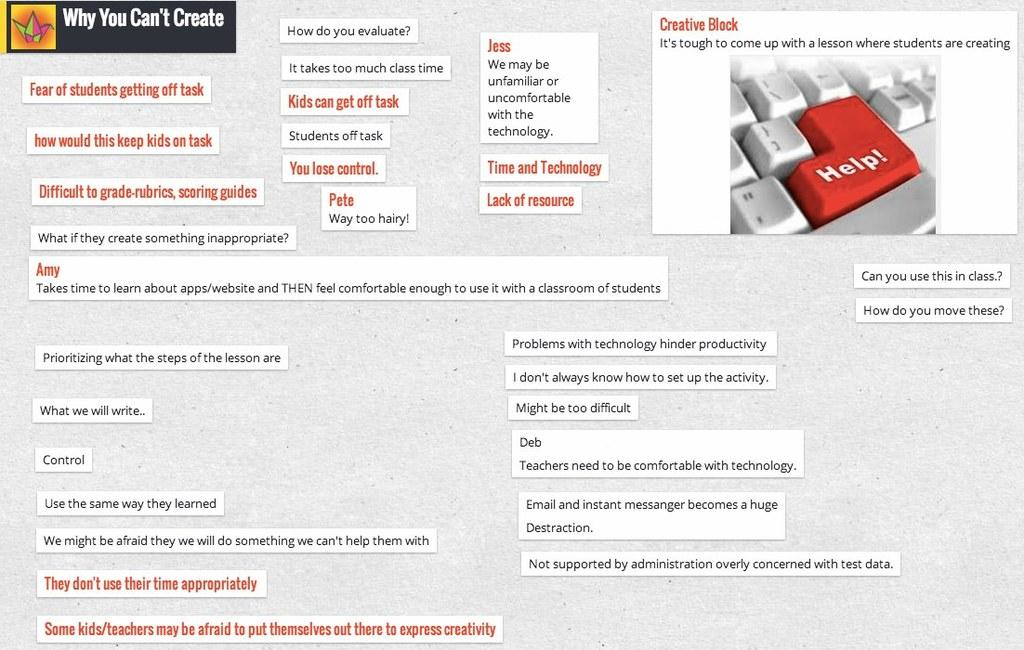What type of content is displayed in the image? The image contains a screenshot of a picture. What else can be seen in the screenshot besides the picture? There is text present in the screenshot. Can you describe the picture on the right side of the screenshot? There is a picture of a keyboard on the right side of the screenshot. What type of shoe is visible in the image? There is no shoe present in the image; it contains a screenshot with text and a picture of a keyboard. 